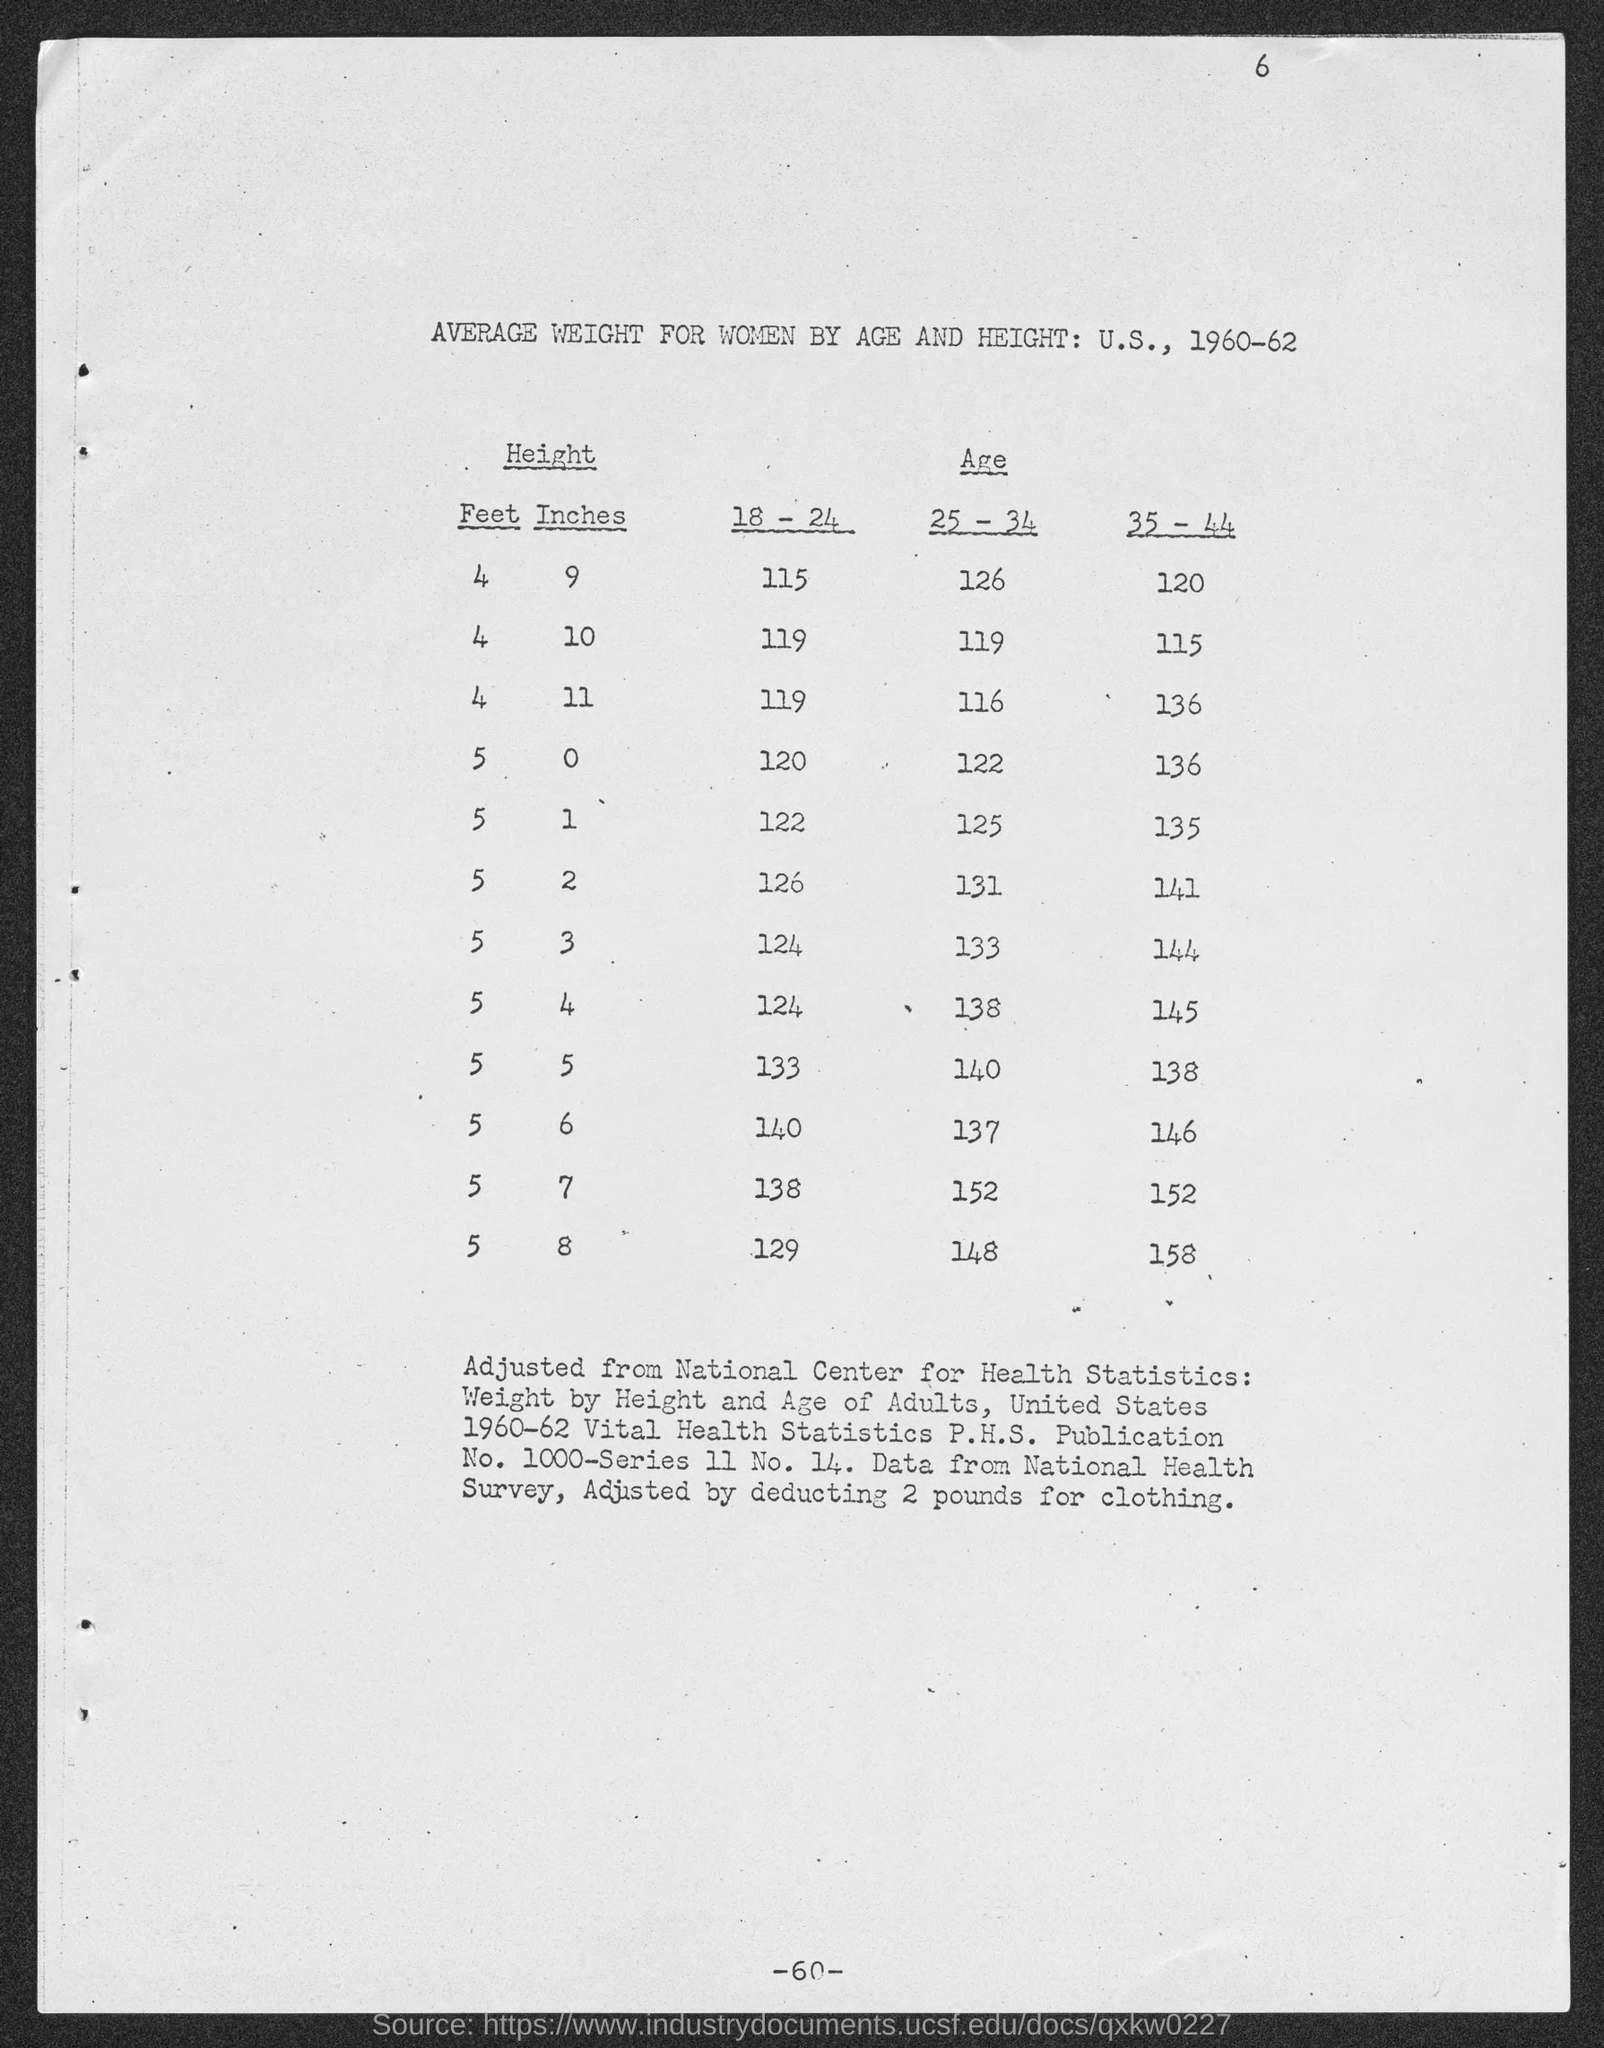What is the table title? The title of the table is 'Average Weight for Women by Age and Height: U.S., 1960-62'. This data provides a fascinating snapshot of the health and anthropometric statistics collected during the early 1960s, reflecting the average weights of women across different age and height categories in that era. 